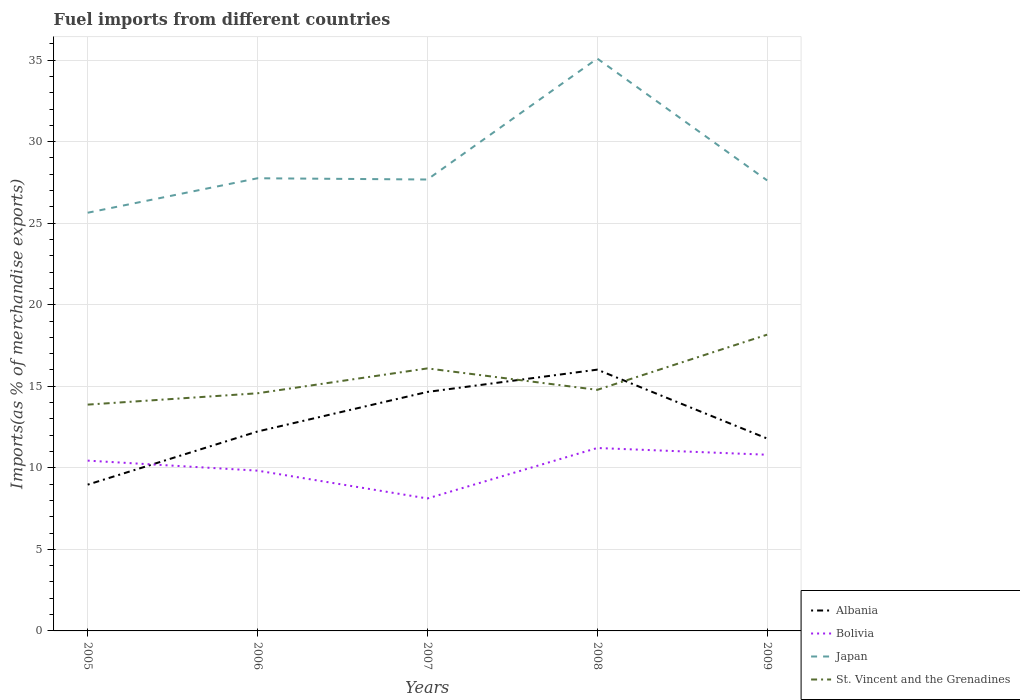Across all years, what is the maximum percentage of imports to different countries in Albania?
Your answer should be very brief. 8.97. What is the total percentage of imports to different countries in Bolivia in the graph?
Make the answer very short. 0.61. What is the difference between the highest and the second highest percentage of imports to different countries in Albania?
Offer a very short reply. 7.05. Is the percentage of imports to different countries in Albania strictly greater than the percentage of imports to different countries in St. Vincent and the Grenadines over the years?
Offer a terse response. No. What is the title of the graph?
Provide a short and direct response. Fuel imports from different countries. What is the label or title of the Y-axis?
Your answer should be compact. Imports(as % of merchandise exports). What is the Imports(as % of merchandise exports) in Albania in 2005?
Make the answer very short. 8.97. What is the Imports(as % of merchandise exports) in Bolivia in 2005?
Provide a succinct answer. 10.44. What is the Imports(as % of merchandise exports) of Japan in 2005?
Your response must be concise. 25.64. What is the Imports(as % of merchandise exports) of St. Vincent and the Grenadines in 2005?
Provide a short and direct response. 13.88. What is the Imports(as % of merchandise exports) in Albania in 2006?
Give a very brief answer. 12.23. What is the Imports(as % of merchandise exports) of Bolivia in 2006?
Your answer should be compact. 9.83. What is the Imports(as % of merchandise exports) in Japan in 2006?
Your answer should be very brief. 27.76. What is the Imports(as % of merchandise exports) in St. Vincent and the Grenadines in 2006?
Provide a short and direct response. 14.57. What is the Imports(as % of merchandise exports) in Albania in 2007?
Your answer should be compact. 14.66. What is the Imports(as % of merchandise exports) in Bolivia in 2007?
Your answer should be very brief. 8.12. What is the Imports(as % of merchandise exports) of Japan in 2007?
Provide a short and direct response. 27.68. What is the Imports(as % of merchandise exports) of St. Vincent and the Grenadines in 2007?
Keep it short and to the point. 16.1. What is the Imports(as % of merchandise exports) in Albania in 2008?
Offer a terse response. 16.02. What is the Imports(as % of merchandise exports) in Bolivia in 2008?
Your response must be concise. 11.22. What is the Imports(as % of merchandise exports) of Japan in 2008?
Ensure brevity in your answer.  35.1. What is the Imports(as % of merchandise exports) in St. Vincent and the Grenadines in 2008?
Provide a succinct answer. 14.78. What is the Imports(as % of merchandise exports) of Albania in 2009?
Give a very brief answer. 11.8. What is the Imports(as % of merchandise exports) of Bolivia in 2009?
Offer a very short reply. 10.8. What is the Imports(as % of merchandise exports) in Japan in 2009?
Give a very brief answer. 27.63. What is the Imports(as % of merchandise exports) in St. Vincent and the Grenadines in 2009?
Offer a very short reply. 18.17. Across all years, what is the maximum Imports(as % of merchandise exports) of Albania?
Your answer should be compact. 16.02. Across all years, what is the maximum Imports(as % of merchandise exports) of Bolivia?
Ensure brevity in your answer.  11.22. Across all years, what is the maximum Imports(as % of merchandise exports) of Japan?
Your answer should be very brief. 35.1. Across all years, what is the maximum Imports(as % of merchandise exports) in St. Vincent and the Grenadines?
Ensure brevity in your answer.  18.17. Across all years, what is the minimum Imports(as % of merchandise exports) in Albania?
Keep it short and to the point. 8.97. Across all years, what is the minimum Imports(as % of merchandise exports) of Bolivia?
Keep it short and to the point. 8.12. Across all years, what is the minimum Imports(as % of merchandise exports) of Japan?
Offer a very short reply. 25.64. Across all years, what is the minimum Imports(as % of merchandise exports) in St. Vincent and the Grenadines?
Ensure brevity in your answer.  13.88. What is the total Imports(as % of merchandise exports) in Albania in the graph?
Provide a short and direct response. 63.67. What is the total Imports(as % of merchandise exports) of Bolivia in the graph?
Offer a terse response. 50.41. What is the total Imports(as % of merchandise exports) in Japan in the graph?
Offer a terse response. 143.8. What is the total Imports(as % of merchandise exports) in St. Vincent and the Grenadines in the graph?
Provide a short and direct response. 77.5. What is the difference between the Imports(as % of merchandise exports) of Albania in 2005 and that in 2006?
Offer a terse response. -3.26. What is the difference between the Imports(as % of merchandise exports) in Bolivia in 2005 and that in 2006?
Your response must be concise. 0.61. What is the difference between the Imports(as % of merchandise exports) in Japan in 2005 and that in 2006?
Provide a succinct answer. -2.11. What is the difference between the Imports(as % of merchandise exports) of St. Vincent and the Grenadines in 2005 and that in 2006?
Your answer should be very brief. -0.7. What is the difference between the Imports(as % of merchandise exports) in Albania in 2005 and that in 2007?
Offer a terse response. -5.69. What is the difference between the Imports(as % of merchandise exports) of Bolivia in 2005 and that in 2007?
Keep it short and to the point. 2.32. What is the difference between the Imports(as % of merchandise exports) of Japan in 2005 and that in 2007?
Make the answer very short. -2.04. What is the difference between the Imports(as % of merchandise exports) in St. Vincent and the Grenadines in 2005 and that in 2007?
Offer a very short reply. -2.22. What is the difference between the Imports(as % of merchandise exports) of Albania in 2005 and that in 2008?
Your answer should be very brief. -7.05. What is the difference between the Imports(as % of merchandise exports) of Bolivia in 2005 and that in 2008?
Provide a succinct answer. -0.77. What is the difference between the Imports(as % of merchandise exports) of Japan in 2005 and that in 2008?
Ensure brevity in your answer.  -9.45. What is the difference between the Imports(as % of merchandise exports) of St. Vincent and the Grenadines in 2005 and that in 2008?
Your answer should be very brief. -0.91. What is the difference between the Imports(as % of merchandise exports) of Albania in 2005 and that in 2009?
Offer a very short reply. -2.83. What is the difference between the Imports(as % of merchandise exports) of Bolivia in 2005 and that in 2009?
Provide a succinct answer. -0.36. What is the difference between the Imports(as % of merchandise exports) of Japan in 2005 and that in 2009?
Your response must be concise. -1.98. What is the difference between the Imports(as % of merchandise exports) in St. Vincent and the Grenadines in 2005 and that in 2009?
Your answer should be compact. -4.29. What is the difference between the Imports(as % of merchandise exports) in Albania in 2006 and that in 2007?
Offer a terse response. -2.43. What is the difference between the Imports(as % of merchandise exports) in Bolivia in 2006 and that in 2007?
Make the answer very short. 1.71. What is the difference between the Imports(as % of merchandise exports) of Japan in 2006 and that in 2007?
Your answer should be very brief. 0.08. What is the difference between the Imports(as % of merchandise exports) in St. Vincent and the Grenadines in 2006 and that in 2007?
Offer a very short reply. -1.52. What is the difference between the Imports(as % of merchandise exports) in Albania in 2006 and that in 2008?
Make the answer very short. -3.79. What is the difference between the Imports(as % of merchandise exports) of Bolivia in 2006 and that in 2008?
Make the answer very short. -1.39. What is the difference between the Imports(as % of merchandise exports) in Japan in 2006 and that in 2008?
Ensure brevity in your answer.  -7.34. What is the difference between the Imports(as % of merchandise exports) of St. Vincent and the Grenadines in 2006 and that in 2008?
Make the answer very short. -0.21. What is the difference between the Imports(as % of merchandise exports) of Albania in 2006 and that in 2009?
Offer a very short reply. 0.43. What is the difference between the Imports(as % of merchandise exports) in Bolivia in 2006 and that in 2009?
Keep it short and to the point. -0.98. What is the difference between the Imports(as % of merchandise exports) of Japan in 2006 and that in 2009?
Keep it short and to the point. 0.13. What is the difference between the Imports(as % of merchandise exports) of St. Vincent and the Grenadines in 2006 and that in 2009?
Give a very brief answer. -3.59. What is the difference between the Imports(as % of merchandise exports) of Albania in 2007 and that in 2008?
Your answer should be compact. -1.37. What is the difference between the Imports(as % of merchandise exports) in Bolivia in 2007 and that in 2008?
Give a very brief answer. -3.09. What is the difference between the Imports(as % of merchandise exports) in Japan in 2007 and that in 2008?
Give a very brief answer. -7.42. What is the difference between the Imports(as % of merchandise exports) of St. Vincent and the Grenadines in 2007 and that in 2008?
Your answer should be very brief. 1.31. What is the difference between the Imports(as % of merchandise exports) in Albania in 2007 and that in 2009?
Your answer should be compact. 2.86. What is the difference between the Imports(as % of merchandise exports) in Bolivia in 2007 and that in 2009?
Your response must be concise. -2.68. What is the difference between the Imports(as % of merchandise exports) of Japan in 2007 and that in 2009?
Your response must be concise. 0.05. What is the difference between the Imports(as % of merchandise exports) in St. Vincent and the Grenadines in 2007 and that in 2009?
Make the answer very short. -2.07. What is the difference between the Imports(as % of merchandise exports) in Albania in 2008 and that in 2009?
Keep it short and to the point. 4.22. What is the difference between the Imports(as % of merchandise exports) of Bolivia in 2008 and that in 2009?
Ensure brevity in your answer.  0.41. What is the difference between the Imports(as % of merchandise exports) in Japan in 2008 and that in 2009?
Give a very brief answer. 7.47. What is the difference between the Imports(as % of merchandise exports) of St. Vincent and the Grenadines in 2008 and that in 2009?
Keep it short and to the point. -3.38. What is the difference between the Imports(as % of merchandise exports) in Albania in 2005 and the Imports(as % of merchandise exports) in Bolivia in 2006?
Ensure brevity in your answer.  -0.86. What is the difference between the Imports(as % of merchandise exports) in Albania in 2005 and the Imports(as % of merchandise exports) in Japan in 2006?
Ensure brevity in your answer.  -18.79. What is the difference between the Imports(as % of merchandise exports) in Albania in 2005 and the Imports(as % of merchandise exports) in St. Vincent and the Grenadines in 2006?
Offer a very short reply. -5.6. What is the difference between the Imports(as % of merchandise exports) in Bolivia in 2005 and the Imports(as % of merchandise exports) in Japan in 2006?
Offer a terse response. -17.31. What is the difference between the Imports(as % of merchandise exports) in Bolivia in 2005 and the Imports(as % of merchandise exports) in St. Vincent and the Grenadines in 2006?
Offer a terse response. -4.13. What is the difference between the Imports(as % of merchandise exports) in Japan in 2005 and the Imports(as % of merchandise exports) in St. Vincent and the Grenadines in 2006?
Offer a very short reply. 11.07. What is the difference between the Imports(as % of merchandise exports) of Albania in 2005 and the Imports(as % of merchandise exports) of Bolivia in 2007?
Ensure brevity in your answer.  0.85. What is the difference between the Imports(as % of merchandise exports) in Albania in 2005 and the Imports(as % of merchandise exports) in Japan in 2007?
Your response must be concise. -18.71. What is the difference between the Imports(as % of merchandise exports) of Albania in 2005 and the Imports(as % of merchandise exports) of St. Vincent and the Grenadines in 2007?
Provide a short and direct response. -7.13. What is the difference between the Imports(as % of merchandise exports) in Bolivia in 2005 and the Imports(as % of merchandise exports) in Japan in 2007?
Offer a very short reply. -17.24. What is the difference between the Imports(as % of merchandise exports) in Bolivia in 2005 and the Imports(as % of merchandise exports) in St. Vincent and the Grenadines in 2007?
Make the answer very short. -5.65. What is the difference between the Imports(as % of merchandise exports) of Japan in 2005 and the Imports(as % of merchandise exports) of St. Vincent and the Grenadines in 2007?
Ensure brevity in your answer.  9.55. What is the difference between the Imports(as % of merchandise exports) of Albania in 2005 and the Imports(as % of merchandise exports) of Bolivia in 2008?
Offer a terse response. -2.25. What is the difference between the Imports(as % of merchandise exports) of Albania in 2005 and the Imports(as % of merchandise exports) of Japan in 2008?
Offer a very short reply. -26.13. What is the difference between the Imports(as % of merchandise exports) in Albania in 2005 and the Imports(as % of merchandise exports) in St. Vincent and the Grenadines in 2008?
Keep it short and to the point. -5.81. What is the difference between the Imports(as % of merchandise exports) of Bolivia in 2005 and the Imports(as % of merchandise exports) of Japan in 2008?
Your answer should be compact. -24.65. What is the difference between the Imports(as % of merchandise exports) of Bolivia in 2005 and the Imports(as % of merchandise exports) of St. Vincent and the Grenadines in 2008?
Offer a very short reply. -4.34. What is the difference between the Imports(as % of merchandise exports) in Japan in 2005 and the Imports(as % of merchandise exports) in St. Vincent and the Grenadines in 2008?
Your answer should be very brief. 10.86. What is the difference between the Imports(as % of merchandise exports) in Albania in 2005 and the Imports(as % of merchandise exports) in Bolivia in 2009?
Provide a short and direct response. -1.83. What is the difference between the Imports(as % of merchandise exports) in Albania in 2005 and the Imports(as % of merchandise exports) in Japan in 2009?
Provide a short and direct response. -18.66. What is the difference between the Imports(as % of merchandise exports) of Albania in 2005 and the Imports(as % of merchandise exports) of St. Vincent and the Grenadines in 2009?
Make the answer very short. -9.2. What is the difference between the Imports(as % of merchandise exports) of Bolivia in 2005 and the Imports(as % of merchandise exports) of Japan in 2009?
Keep it short and to the point. -17.18. What is the difference between the Imports(as % of merchandise exports) in Bolivia in 2005 and the Imports(as % of merchandise exports) in St. Vincent and the Grenadines in 2009?
Ensure brevity in your answer.  -7.72. What is the difference between the Imports(as % of merchandise exports) in Japan in 2005 and the Imports(as % of merchandise exports) in St. Vincent and the Grenadines in 2009?
Provide a short and direct response. 7.48. What is the difference between the Imports(as % of merchandise exports) in Albania in 2006 and the Imports(as % of merchandise exports) in Bolivia in 2007?
Make the answer very short. 4.11. What is the difference between the Imports(as % of merchandise exports) in Albania in 2006 and the Imports(as % of merchandise exports) in Japan in 2007?
Your response must be concise. -15.45. What is the difference between the Imports(as % of merchandise exports) in Albania in 2006 and the Imports(as % of merchandise exports) in St. Vincent and the Grenadines in 2007?
Your answer should be compact. -3.87. What is the difference between the Imports(as % of merchandise exports) in Bolivia in 2006 and the Imports(as % of merchandise exports) in Japan in 2007?
Your response must be concise. -17.85. What is the difference between the Imports(as % of merchandise exports) of Bolivia in 2006 and the Imports(as % of merchandise exports) of St. Vincent and the Grenadines in 2007?
Keep it short and to the point. -6.27. What is the difference between the Imports(as % of merchandise exports) in Japan in 2006 and the Imports(as % of merchandise exports) in St. Vincent and the Grenadines in 2007?
Make the answer very short. 11.66. What is the difference between the Imports(as % of merchandise exports) of Albania in 2006 and the Imports(as % of merchandise exports) of Bolivia in 2008?
Offer a terse response. 1.01. What is the difference between the Imports(as % of merchandise exports) of Albania in 2006 and the Imports(as % of merchandise exports) of Japan in 2008?
Give a very brief answer. -22.87. What is the difference between the Imports(as % of merchandise exports) of Albania in 2006 and the Imports(as % of merchandise exports) of St. Vincent and the Grenadines in 2008?
Your response must be concise. -2.55. What is the difference between the Imports(as % of merchandise exports) of Bolivia in 2006 and the Imports(as % of merchandise exports) of Japan in 2008?
Your answer should be very brief. -25.27. What is the difference between the Imports(as % of merchandise exports) of Bolivia in 2006 and the Imports(as % of merchandise exports) of St. Vincent and the Grenadines in 2008?
Ensure brevity in your answer.  -4.96. What is the difference between the Imports(as % of merchandise exports) of Japan in 2006 and the Imports(as % of merchandise exports) of St. Vincent and the Grenadines in 2008?
Your answer should be compact. 12.97. What is the difference between the Imports(as % of merchandise exports) of Albania in 2006 and the Imports(as % of merchandise exports) of Bolivia in 2009?
Your response must be concise. 1.43. What is the difference between the Imports(as % of merchandise exports) in Albania in 2006 and the Imports(as % of merchandise exports) in Japan in 2009?
Keep it short and to the point. -15.4. What is the difference between the Imports(as % of merchandise exports) in Albania in 2006 and the Imports(as % of merchandise exports) in St. Vincent and the Grenadines in 2009?
Provide a succinct answer. -5.94. What is the difference between the Imports(as % of merchandise exports) in Bolivia in 2006 and the Imports(as % of merchandise exports) in Japan in 2009?
Your answer should be very brief. -17.8. What is the difference between the Imports(as % of merchandise exports) in Bolivia in 2006 and the Imports(as % of merchandise exports) in St. Vincent and the Grenadines in 2009?
Offer a very short reply. -8.34. What is the difference between the Imports(as % of merchandise exports) of Japan in 2006 and the Imports(as % of merchandise exports) of St. Vincent and the Grenadines in 2009?
Keep it short and to the point. 9.59. What is the difference between the Imports(as % of merchandise exports) of Albania in 2007 and the Imports(as % of merchandise exports) of Bolivia in 2008?
Offer a very short reply. 3.44. What is the difference between the Imports(as % of merchandise exports) of Albania in 2007 and the Imports(as % of merchandise exports) of Japan in 2008?
Provide a short and direct response. -20.44. What is the difference between the Imports(as % of merchandise exports) in Albania in 2007 and the Imports(as % of merchandise exports) in St. Vincent and the Grenadines in 2008?
Provide a succinct answer. -0.13. What is the difference between the Imports(as % of merchandise exports) of Bolivia in 2007 and the Imports(as % of merchandise exports) of Japan in 2008?
Your answer should be compact. -26.97. What is the difference between the Imports(as % of merchandise exports) in Bolivia in 2007 and the Imports(as % of merchandise exports) in St. Vincent and the Grenadines in 2008?
Ensure brevity in your answer.  -6.66. What is the difference between the Imports(as % of merchandise exports) in Japan in 2007 and the Imports(as % of merchandise exports) in St. Vincent and the Grenadines in 2008?
Keep it short and to the point. 12.9. What is the difference between the Imports(as % of merchandise exports) in Albania in 2007 and the Imports(as % of merchandise exports) in Bolivia in 2009?
Your response must be concise. 3.85. What is the difference between the Imports(as % of merchandise exports) in Albania in 2007 and the Imports(as % of merchandise exports) in Japan in 2009?
Provide a short and direct response. -12.97. What is the difference between the Imports(as % of merchandise exports) of Albania in 2007 and the Imports(as % of merchandise exports) of St. Vincent and the Grenadines in 2009?
Offer a terse response. -3.51. What is the difference between the Imports(as % of merchandise exports) of Bolivia in 2007 and the Imports(as % of merchandise exports) of Japan in 2009?
Your response must be concise. -19.5. What is the difference between the Imports(as % of merchandise exports) of Bolivia in 2007 and the Imports(as % of merchandise exports) of St. Vincent and the Grenadines in 2009?
Your answer should be compact. -10.04. What is the difference between the Imports(as % of merchandise exports) in Japan in 2007 and the Imports(as % of merchandise exports) in St. Vincent and the Grenadines in 2009?
Provide a short and direct response. 9.51. What is the difference between the Imports(as % of merchandise exports) in Albania in 2008 and the Imports(as % of merchandise exports) in Bolivia in 2009?
Keep it short and to the point. 5.22. What is the difference between the Imports(as % of merchandise exports) in Albania in 2008 and the Imports(as % of merchandise exports) in Japan in 2009?
Give a very brief answer. -11.6. What is the difference between the Imports(as % of merchandise exports) of Albania in 2008 and the Imports(as % of merchandise exports) of St. Vincent and the Grenadines in 2009?
Provide a short and direct response. -2.14. What is the difference between the Imports(as % of merchandise exports) of Bolivia in 2008 and the Imports(as % of merchandise exports) of Japan in 2009?
Your answer should be very brief. -16.41. What is the difference between the Imports(as % of merchandise exports) in Bolivia in 2008 and the Imports(as % of merchandise exports) in St. Vincent and the Grenadines in 2009?
Ensure brevity in your answer.  -6.95. What is the difference between the Imports(as % of merchandise exports) of Japan in 2008 and the Imports(as % of merchandise exports) of St. Vincent and the Grenadines in 2009?
Give a very brief answer. 16.93. What is the average Imports(as % of merchandise exports) in Albania per year?
Your answer should be compact. 12.73. What is the average Imports(as % of merchandise exports) in Bolivia per year?
Keep it short and to the point. 10.08. What is the average Imports(as % of merchandise exports) of Japan per year?
Ensure brevity in your answer.  28.76. What is the average Imports(as % of merchandise exports) in St. Vincent and the Grenadines per year?
Your response must be concise. 15.5. In the year 2005, what is the difference between the Imports(as % of merchandise exports) in Albania and Imports(as % of merchandise exports) in Bolivia?
Provide a succinct answer. -1.47. In the year 2005, what is the difference between the Imports(as % of merchandise exports) of Albania and Imports(as % of merchandise exports) of Japan?
Your answer should be compact. -16.67. In the year 2005, what is the difference between the Imports(as % of merchandise exports) of Albania and Imports(as % of merchandise exports) of St. Vincent and the Grenadines?
Give a very brief answer. -4.91. In the year 2005, what is the difference between the Imports(as % of merchandise exports) of Bolivia and Imports(as % of merchandise exports) of Japan?
Offer a very short reply. -15.2. In the year 2005, what is the difference between the Imports(as % of merchandise exports) in Bolivia and Imports(as % of merchandise exports) in St. Vincent and the Grenadines?
Your answer should be very brief. -3.43. In the year 2005, what is the difference between the Imports(as % of merchandise exports) in Japan and Imports(as % of merchandise exports) in St. Vincent and the Grenadines?
Provide a short and direct response. 11.77. In the year 2006, what is the difference between the Imports(as % of merchandise exports) in Albania and Imports(as % of merchandise exports) in Bolivia?
Your answer should be very brief. 2.4. In the year 2006, what is the difference between the Imports(as % of merchandise exports) of Albania and Imports(as % of merchandise exports) of Japan?
Give a very brief answer. -15.53. In the year 2006, what is the difference between the Imports(as % of merchandise exports) in Albania and Imports(as % of merchandise exports) in St. Vincent and the Grenadines?
Provide a succinct answer. -2.34. In the year 2006, what is the difference between the Imports(as % of merchandise exports) of Bolivia and Imports(as % of merchandise exports) of Japan?
Provide a succinct answer. -17.93. In the year 2006, what is the difference between the Imports(as % of merchandise exports) of Bolivia and Imports(as % of merchandise exports) of St. Vincent and the Grenadines?
Provide a succinct answer. -4.74. In the year 2006, what is the difference between the Imports(as % of merchandise exports) in Japan and Imports(as % of merchandise exports) in St. Vincent and the Grenadines?
Your answer should be very brief. 13.18. In the year 2007, what is the difference between the Imports(as % of merchandise exports) in Albania and Imports(as % of merchandise exports) in Bolivia?
Offer a terse response. 6.53. In the year 2007, what is the difference between the Imports(as % of merchandise exports) of Albania and Imports(as % of merchandise exports) of Japan?
Provide a succinct answer. -13.03. In the year 2007, what is the difference between the Imports(as % of merchandise exports) in Albania and Imports(as % of merchandise exports) in St. Vincent and the Grenadines?
Your answer should be compact. -1.44. In the year 2007, what is the difference between the Imports(as % of merchandise exports) in Bolivia and Imports(as % of merchandise exports) in Japan?
Offer a very short reply. -19.56. In the year 2007, what is the difference between the Imports(as % of merchandise exports) of Bolivia and Imports(as % of merchandise exports) of St. Vincent and the Grenadines?
Ensure brevity in your answer.  -7.97. In the year 2007, what is the difference between the Imports(as % of merchandise exports) of Japan and Imports(as % of merchandise exports) of St. Vincent and the Grenadines?
Make the answer very short. 11.58. In the year 2008, what is the difference between the Imports(as % of merchandise exports) of Albania and Imports(as % of merchandise exports) of Bolivia?
Offer a very short reply. 4.8. In the year 2008, what is the difference between the Imports(as % of merchandise exports) in Albania and Imports(as % of merchandise exports) in Japan?
Your answer should be compact. -19.07. In the year 2008, what is the difference between the Imports(as % of merchandise exports) in Albania and Imports(as % of merchandise exports) in St. Vincent and the Grenadines?
Your response must be concise. 1.24. In the year 2008, what is the difference between the Imports(as % of merchandise exports) in Bolivia and Imports(as % of merchandise exports) in Japan?
Your response must be concise. -23.88. In the year 2008, what is the difference between the Imports(as % of merchandise exports) in Bolivia and Imports(as % of merchandise exports) in St. Vincent and the Grenadines?
Ensure brevity in your answer.  -3.57. In the year 2008, what is the difference between the Imports(as % of merchandise exports) of Japan and Imports(as % of merchandise exports) of St. Vincent and the Grenadines?
Offer a very short reply. 20.31. In the year 2009, what is the difference between the Imports(as % of merchandise exports) of Albania and Imports(as % of merchandise exports) of Japan?
Provide a short and direct response. -15.83. In the year 2009, what is the difference between the Imports(as % of merchandise exports) of Albania and Imports(as % of merchandise exports) of St. Vincent and the Grenadines?
Offer a terse response. -6.37. In the year 2009, what is the difference between the Imports(as % of merchandise exports) in Bolivia and Imports(as % of merchandise exports) in Japan?
Keep it short and to the point. -16.82. In the year 2009, what is the difference between the Imports(as % of merchandise exports) of Bolivia and Imports(as % of merchandise exports) of St. Vincent and the Grenadines?
Your answer should be very brief. -7.36. In the year 2009, what is the difference between the Imports(as % of merchandise exports) in Japan and Imports(as % of merchandise exports) in St. Vincent and the Grenadines?
Give a very brief answer. 9.46. What is the ratio of the Imports(as % of merchandise exports) of Albania in 2005 to that in 2006?
Offer a terse response. 0.73. What is the ratio of the Imports(as % of merchandise exports) in Bolivia in 2005 to that in 2006?
Your response must be concise. 1.06. What is the ratio of the Imports(as % of merchandise exports) in Japan in 2005 to that in 2006?
Make the answer very short. 0.92. What is the ratio of the Imports(as % of merchandise exports) in St. Vincent and the Grenadines in 2005 to that in 2006?
Your answer should be very brief. 0.95. What is the ratio of the Imports(as % of merchandise exports) in Albania in 2005 to that in 2007?
Give a very brief answer. 0.61. What is the ratio of the Imports(as % of merchandise exports) of Japan in 2005 to that in 2007?
Your response must be concise. 0.93. What is the ratio of the Imports(as % of merchandise exports) in St. Vincent and the Grenadines in 2005 to that in 2007?
Your answer should be compact. 0.86. What is the ratio of the Imports(as % of merchandise exports) of Albania in 2005 to that in 2008?
Your answer should be compact. 0.56. What is the ratio of the Imports(as % of merchandise exports) of Bolivia in 2005 to that in 2008?
Make the answer very short. 0.93. What is the ratio of the Imports(as % of merchandise exports) of Japan in 2005 to that in 2008?
Your answer should be compact. 0.73. What is the ratio of the Imports(as % of merchandise exports) of St. Vincent and the Grenadines in 2005 to that in 2008?
Provide a succinct answer. 0.94. What is the ratio of the Imports(as % of merchandise exports) of Albania in 2005 to that in 2009?
Offer a terse response. 0.76. What is the ratio of the Imports(as % of merchandise exports) in Bolivia in 2005 to that in 2009?
Offer a terse response. 0.97. What is the ratio of the Imports(as % of merchandise exports) of Japan in 2005 to that in 2009?
Your response must be concise. 0.93. What is the ratio of the Imports(as % of merchandise exports) of St. Vincent and the Grenadines in 2005 to that in 2009?
Provide a short and direct response. 0.76. What is the ratio of the Imports(as % of merchandise exports) in Albania in 2006 to that in 2007?
Make the answer very short. 0.83. What is the ratio of the Imports(as % of merchandise exports) in Bolivia in 2006 to that in 2007?
Your answer should be compact. 1.21. What is the ratio of the Imports(as % of merchandise exports) in Japan in 2006 to that in 2007?
Your answer should be very brief. 1. What is the ratio of the Imports(as % of merchandise exports) in St. Vincent and the Grenadines in 2006 to that in 2007?
Provide a short and direct response. 0.91. What is the ratio of the Imports(as % of merchandise exports) of Albania in 2006 to that in 2008?
Offer a terse response. 0.76. What is the ratio of the Imports(as % of merchandise exports) of Bolivia in 2006 to that in 2008?
Offer a very short reply. 0.88. What is the ratio of the Imports(as % of merchandise exports) in Japan in 2006 to that in 2008?
Provide a succinct answer. 0.79. What is the ratio of the Imports(as % of merchandise exports) of St. Vincent and the Grenadines in 2006 to that in 2008?
Provide a succinct answer. 0.99. What is the ratio of the Imports(as % of merchandise exports) of Albania in 2006 to that in 2009?
Offer a very short reply. 1.04. What is the ratio of the Imports(as % of merchandise exports) of Bolivia in 2006 to that in 2009?
Provide a succinct answer. 0.91. What is the ratio of the Imports(as % of merchandise exports) of St. Vincent and the Grenadines in 2006 to that in 2009?
Your response must be concise. 0.8. What is the ratio of the Imports(as % of merchandise exports) of Albania in 2007 to that in 2008?
Provide a succinct answer. 0.91. What is the ratio of the Imports(as % of merchandise exports) of Bolivia in 2007 to that in 2008?
Your answer should be compact. 0.72. What is the ratio of the Imports(as % of merchandise exports) in Japan in 2007 to that in 2008?
Provide a short and direct response. 0.79. What is the ratio of the Imports(as % of merchandise exports) of St. Vincent and the Grenadines in 2007 to that in 2008?
Offer a very short reply. 1.09. What is the ratio of the Imports(as % of merchandise exports) of Albania in 2007 to that in 2009?
Provide a succinct answer. 1.24. What is the ratio of the Imports(as % of merchandise exports) of Bolivia in 2007 to that in 2009?
Offer a very short reply. 0.75. What is the ratio of the Imports(as % of merchandise exports) of St. Vincent and the Grenadines in 2007 to that in 2009?
Your answer should be very brief. 0.89. What is the ratio of the Imports(as % of merchandise exports) of Albania in 2008 to that in 2009?
Offer a very short reply. 1.36. What is the ratio of the Imports(as % of merchandise exports) in Bolivia in 2008 to that in 2009?
Your answer should be very brief. 1.04. What is the ratio of the Imports(as % of merchandise exports) in Japan in 2008 to that in 2009?
Give a very brief answer. 1.27. What is the ratio of the Imports(as % of merchandise exports) in St. Vincent and the Grenadines in 2008 to that in 2009?
Your response must be concise. 0.81. What is the difference between the highest and the second highest Imports(as % of merchandise exports) in Albania?
Give a very brief answer. 1.37. What is the difference between the highest and the second highest Imports(as % of merchandise exports) of Bolivia?
Offer a very short reply. 0.41. What is the difference between the highest and the second highest Imports(as % of merchandise exports) in Japan?
Provide a short and direct response. 7.34. What is the difference between the highest and the second highest Imports(as % of merchandise exports) in St. Vincent and the Grenadines?
Provide a short and direct response. 2.07. What is the difference between the highest and the lowest Imports(as % of merchandise exports) in Albania?
Offer a terse response. 7.05. What is the difference between the highest and the lowest Imports(as % of merchandise exports) in Bolivia?
Make the answer very short. 3.09. What is the difference between the highest and the lowest Imports(as % of merchandise exports) in Japan?
Offer a very short reply. 9.45. What is the difference between the highest and the lowest Imports(as % of merchandise exports) in St. Vincent and the Grenadines?
Offer a very short reply. 4.29. 